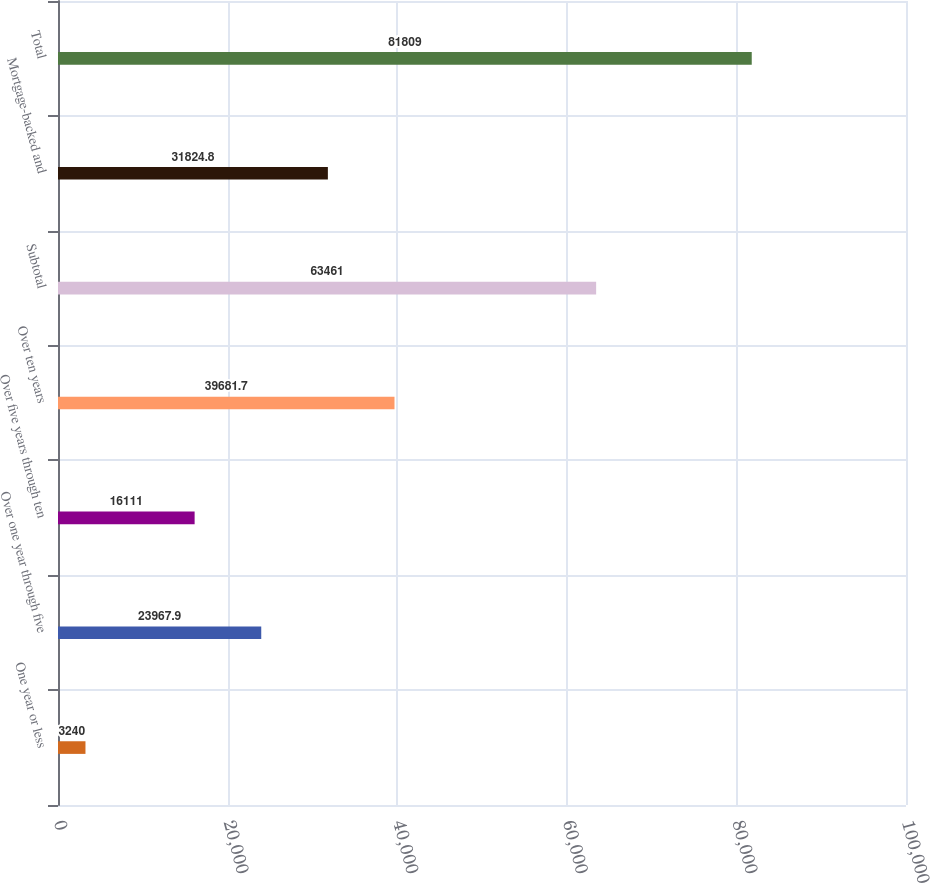Convert chart. <chart><loc_0><loc_0><loc_500><loc_500><bar_chart><fcel>One year or less<fcel>Over one year through five<fcel>Over five years through ten<fcel>Over ten years<fcel>Subtotal<fcel>Mortgage-backed and<fcel>Total<nl><fcel>3240<fcel>23967.9<fcel>16111<fcel>39681.7<fcel>63461<fcel>31824.8<fcel>81809<nl></chart> 